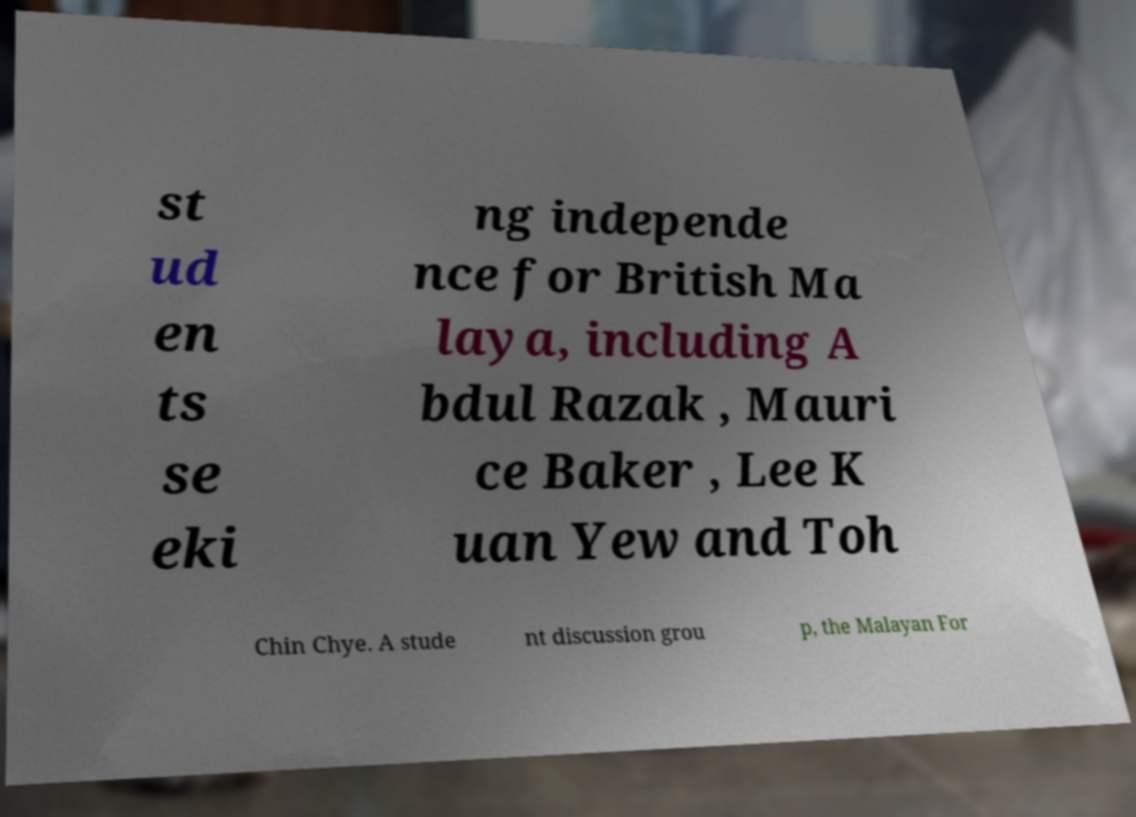Could you extract and type out the text from this image? st ud en ts se eki ng independe nce for British Ma laya, including A bdul Razak , Mauri ce Baker , Lee K uan Yew and Toh Chin Chye. A stude nt discussion grou p, the Malayan For 